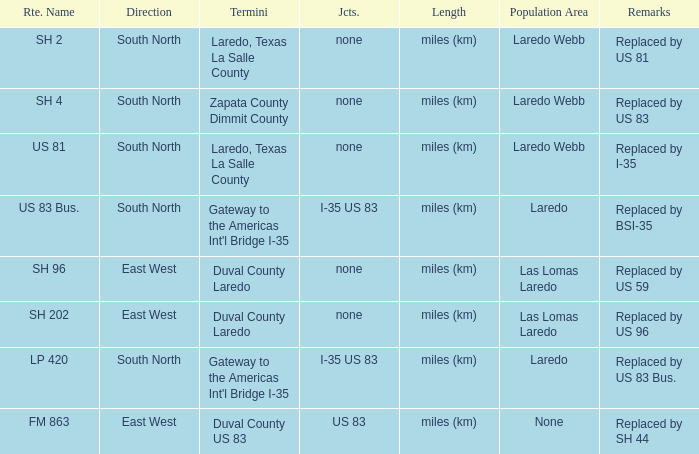Which population areas have "replaced by us 83" listed in their remarks section? Laredo Webb. 